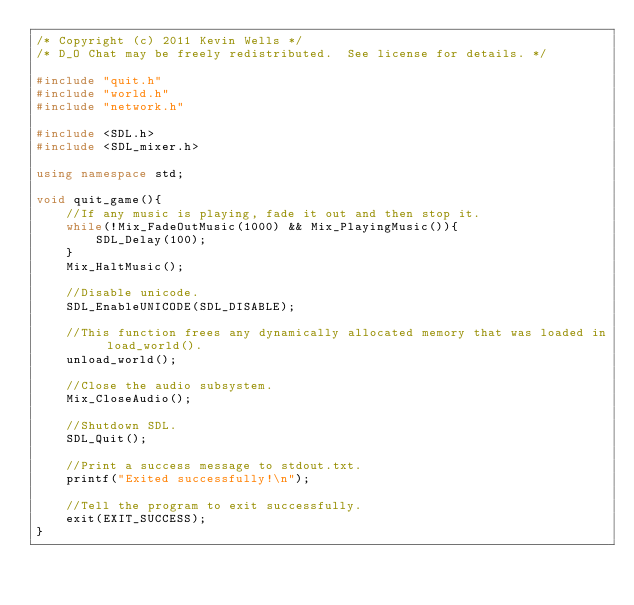<code> <loc_0><loc_0><loc_500><loc_500><_C++_>/* Copyright (c) 2011 Kevin Wells */
/* D_O Chat may be freely redistributed.  See license for details. */

#include "quit.h"
#include "world.h"
#include "network.h"

#include <SDL.h>
#include <SDL_mixer.h>

using namespace std;

void quit_game(){
    //If any music is playing, fade it out and then stop it.
    while(!Mix_FadeOutMusic(1000) && Mix_PlayingMusic()){
        SDL_Delay(100);
    }
    Mix_HaltMusic();

    //Disable unicode.
    SDL_EnableUNICODE(SDL_DISABLE);

    //This function frees any dynamically allocated memory that was loaded in load_world().
    unload_world();

    //Close the audio subsystem.
    Mix_CloseAudio();

    //Shutdown SDL.
    SDL_Quit();

    //Print a success message to stdout.txt.
    printf("Exited successfully!\n");

    //Tell the program to exit successfully.
    exit(EXIT_SUCCESS);
}
</code> 